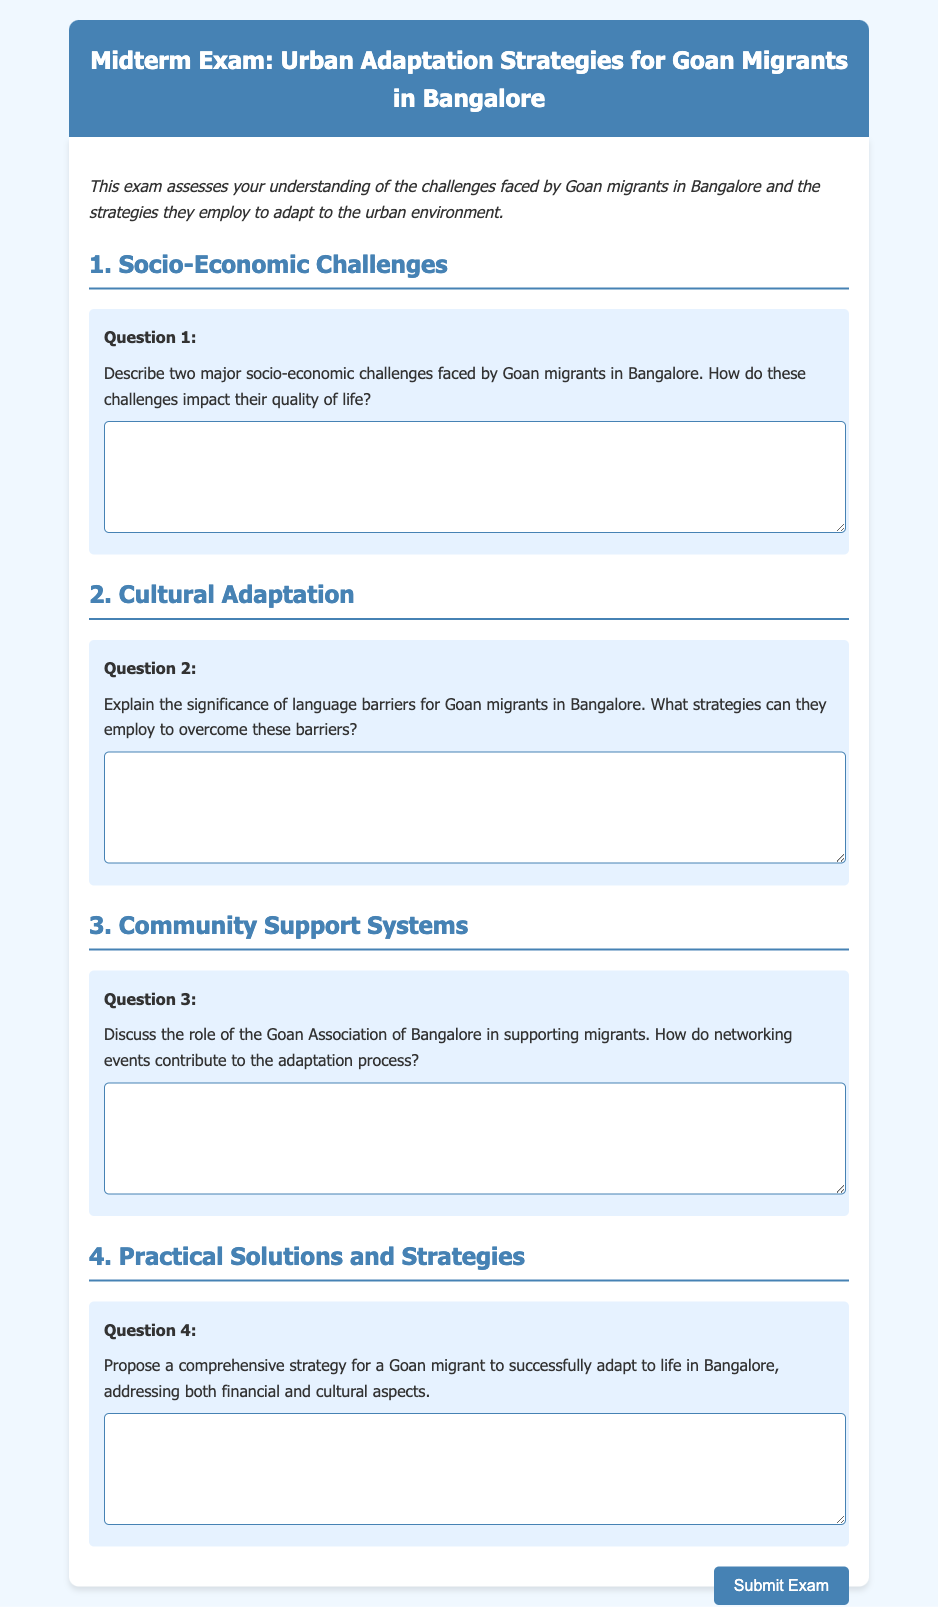What is the title of the exam? The title of the exam is stated clearly at the beginning of the document.
Answer: Midterm Exam: Urban Adaptation Strategies for Goan Migrants in Bangalore What is the first major topic discussed in the exam? The document introduces topics sequentially, starting with the first major topic.
Answer: Socio-Economic Challenges How many questions are included in the exam? The total number of questions is indicated by the sections present in the document.
Answer: Four What organization is mentioned as supporting Goan migrants? The document references a specific organization that aids migrants in Bangalore.
Answer: Goan Association of Bangalore What aspect of adaptation is addressed in Question 4? The content of Question 4 is focused on how migrants can adjust to their new environment.
Answer: Financial and cultural aspects What type of assessment does this document represent? The overall format suggests a specific kind of academic evaluation.
Answer: Midterm Exam Which section discusses language barriers? The document categorizes challenges, highlighting the related section.
Answer: Cultural Adaptation What is the purpose of networking events according to the document? The intended benefit of these events is inferred from the question about community support systems.
Answer: Contribute to the adaptation process What is the primary audience for this exam? The language and context suggest who is intended to take the exam.
Answer: Goan migrants in Bangalore 